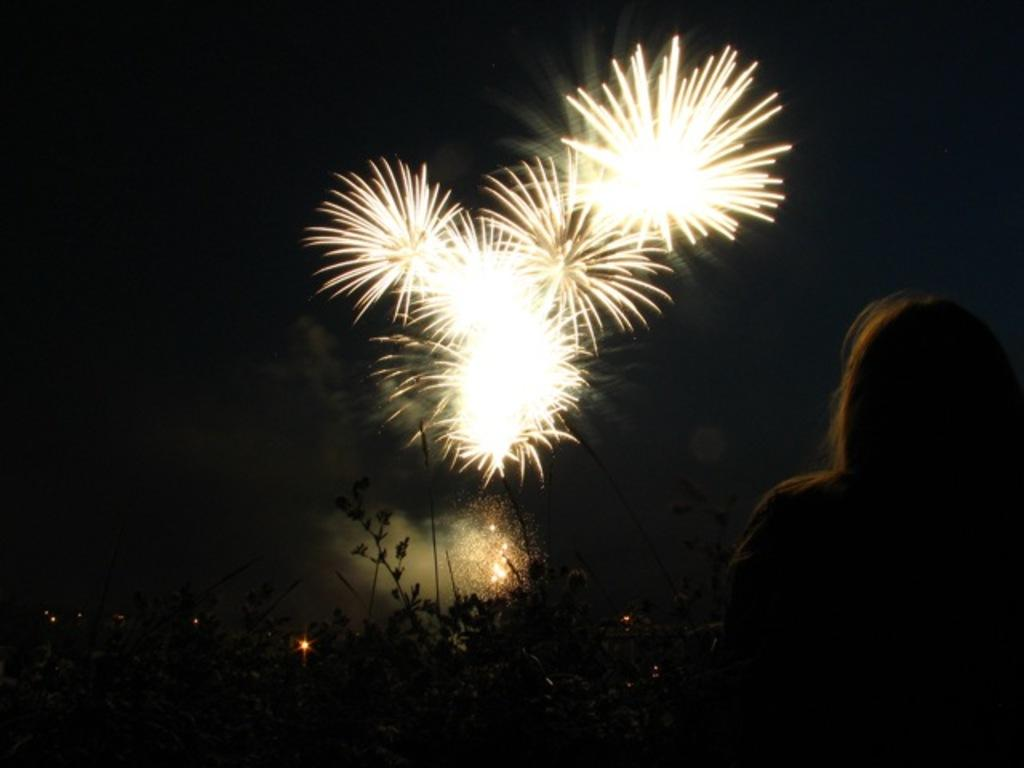Who is present in the image? There is a woman in the image. What is in front of the woman? There are plants in front of the woman. What is happening in the sky in the image? There are firecrackers being burned in the sky. What book is the woman reading in the image? There is no book present in the image, and the woman is not reading. 